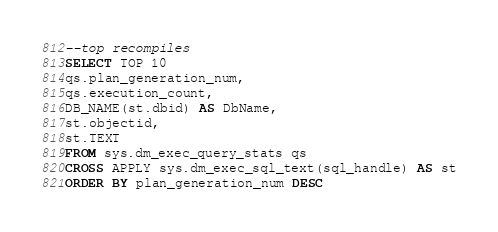<code> <loc_0><loc_0><loc_500><loc_500><_SQL_>--top recompiles
SELECT TOP 10
qs.plan_generation_num,
qs.execution_count,
DB_NAME(st.dbid) AS DbName,
st.objectid,
st.TEXT
FROM sys.dm_exec_query_stats qs
CROSS APPLY sys.dm_exec_sql_text(sql_handle) AS st
ORDER BY plan_generation_num DESC</code> 